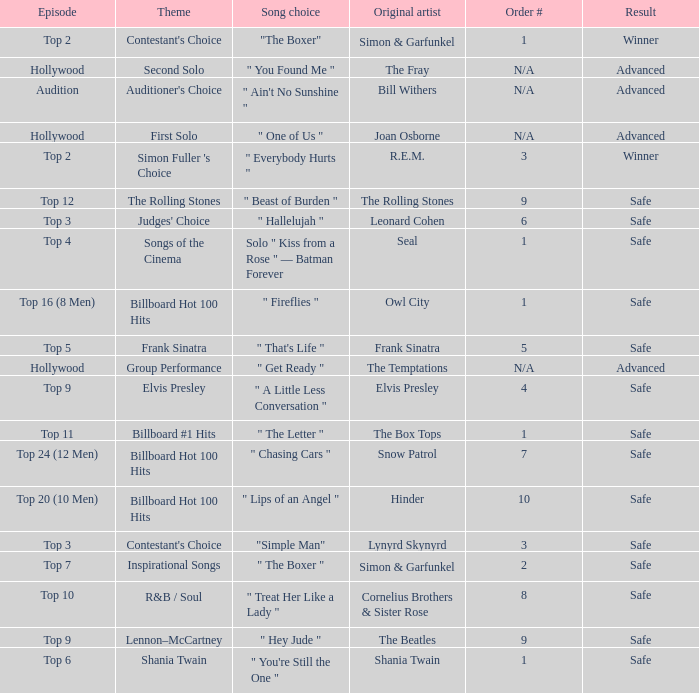Which themes can be found in the song "one of us"? First Solo. 